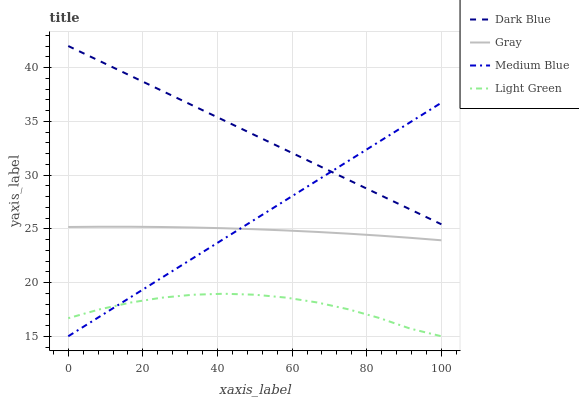Does Light Green have the minimum area under the curve?
Answer yes or no. Yes. Does Dark Blue have the maximum area under the curve?
Answer yes or no. Yes. Does Medium Blue have the minimum area under the curve?
Answer yes or no. No. Does Medium Blue have the maximum area under the curve?
Answer yes or no. No. Is Dark Blue the smoothest?
Answer yes or no. Yes. Is Light Green the roughest?
Answer yes or no. Yes. Is Medium Blue the smoothest?
Answer yes or no. No. Is Medium Blue the roughest?
Answer yes or no. No. Does Gray have the lowest value?
Answer yes or no. No. Does Medium Blue have the highest value?
Answer yes or no. No. Is Gray less than Dark Blue?
Answer yes or no. Yes. Is Gray greater than Light Green?
Answer yes or no. Yes. Does Gray intersect Dark Blue?
Answer yes or no. No. 